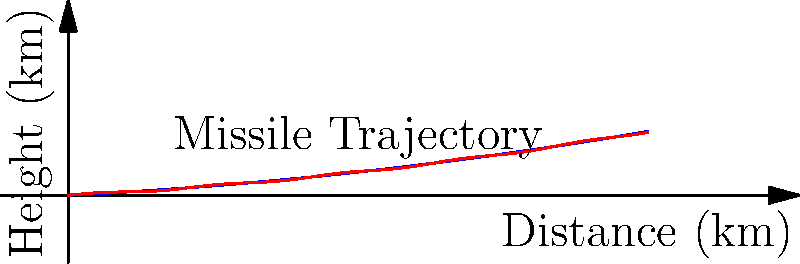Given the graph showing missile trajectories with and without wind effects, which machine learning model would be most suitable for predicting the missile's path considering wind and atmospheric conditions, and why? To answer this question, let's consider the characteristics of the problem and the available machine learning models:

1. The trajectory is non-linear, as shown by the curved paths in the graph.
2. There are multiple input variables (distance, wind speed, atmospheric conditions) affecting the output (height).
3. The relationship between inputs and outputs is complex and potentially time-dependent.
4. We need a model that can capture both the overall trend and local variations due to wind.

Considering these factors:

1. Linear Regression would be inadequate due to the non-linear nature of the trajectories.
2. Decision Trees alone might struggle with the continuous nature of the data and smooth curves.
3. Neural Networks could work but might be overly complex for this task.
4. Support Vector Machines (SVM) with non-linear kernels could be effective but may lack interpretability.

The most suitable model for this task would be a Gaussian Process Regression (GPR) because:

1. GPR can handle non-linear relationships effectively.
2. It provides uncertainty estimates, which is crucial in military applications.
3. GPR can incorporate prior knowledge about the physics of missile trajectories.
4. It can capture both global trends and local variations caused by wind.
5. GPR is data-efficient, which is beneficial when dealing with limited real-world missile trajectory data.
6. It allows for the inclusion of custom kernels that can be tailored to the specific characteristics of missile flight.

Therefore, a Gaussian Process Regression model would be the most suitable for predicting missile trajectories under varying wind and atmospheric conditions.
Answer: Gaussian Process Regression (GPR) 